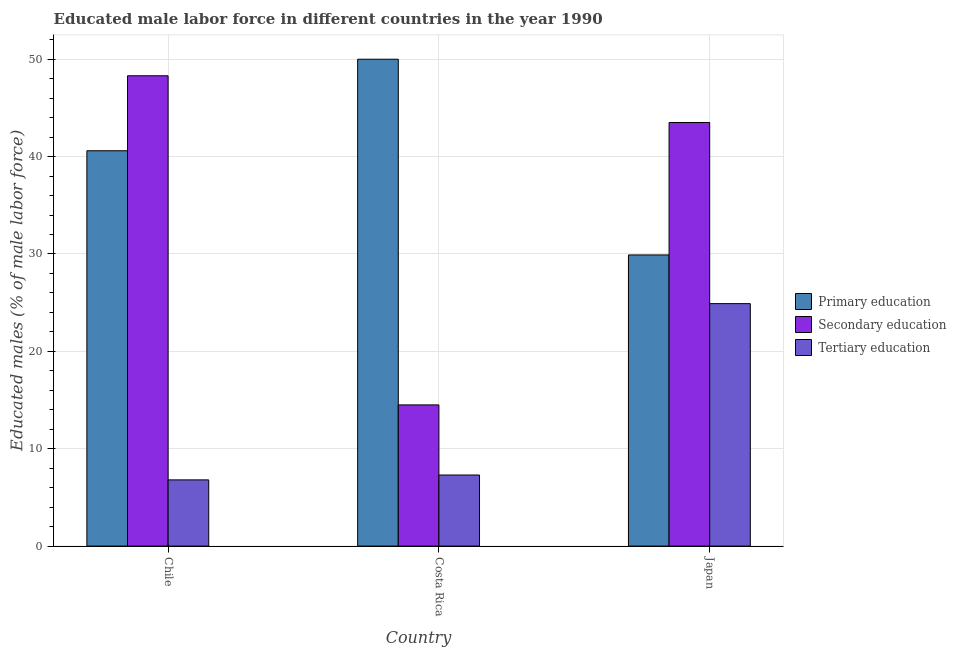How many different coloured bars are there?
Provide a succinct answer. 3. How many groups of bars are there?
Offer a very short reply. 3. Are the number of bars per tick equal to the number of legend labels?
Give a very brief answer. Yes. Are the number of bars on each tick of the X-axis equal?
Your answer should be very brief. Yes. What is the label of the 3rd group of bars from the left?
Your response must be concise. Japan. What is the percentage of male labor force who received primary education in Chile?
Give a very brief answer. 40.6. Across all countries, what is the maximum percentage of male labor force who received secondary education?
Keep it short and to the point. 48.3. Across all countries, what is the minimum percentage of male labor force who received secondary education?
Provide a short and direct response. 14.5. In which country was the percentage of male labor force who received primary education maximum?
Give a very brief answer. Costa Rica. What is the total percentage of male labor force who received tertiary education in the graph?
Offer a terse response. 39. What is the difference between the percentage of male labor force who received primary education in Chile and that in Costa Rica?
Provide a short and direct response. -9.4. What is the difference between the percentage of male labor force who received primary education in Japan and the percentage of male labor force who received tertiary education in Costa Rica?
Provide a short and direct response. 22.6. What is the average percentage of male labor force who received tertiary education per country?
Give a very brief answer. 13. In how many countries, is the percentage of male labor force who received secondary education greater than 18 %?
Give a very brief answer. 2. What is the ratio of the percentage of male labor force who received secondary education in Chile to that in Japan?
Your response must be concise. 1.11. What is the difference between the highest and the second highest percentage of male labor force who received primary education?
Ensure brevity in your answer.  9.4. What is the difference between the highest and the lowest percentage of male labor force who received secondary education?
Make the answer very short. 33.8. Is the sum of the percentage of male labor force who received tertiary education in Chile and Costa Rica greater than the maximum percentage of male labor force who received primary education across all countries?
Offer a very short reply. No. What does the 2nd bar from the left in Costa Rica represents?
Your answer should be compact. Secondary education. Is it the case that in every country, the sum of the percentage of male labor force who received primary education and percentage of male labor force who received secondary education is greater than the percentage of male labor force who received tertiary education?
Your response must be concise. Yes. Are all the bars in the graph horizontal?
Provide a succinct answer. No. Does the graph contain grids?
Ensure brevity in your answer.  Yes. How many legend labels are there?
Offer a terse response. 3. What is the title of the graph?
Offer a terse response. Educated male labor force in different countries in the year 1990. Does "Domestic" appear as one of the legend labels in the graph?
Provide a succinct answer. No. What is the label or title of the X-axis?
Offer a very short reply. Country. What is the label or title of the Y-axis?
Ensure brevity in your answer.  Educated males (% of male labor force). What is the Educated males (% of male labor force) in Primary education in Chile?
Keep it short and to the point. 40.6. What is the Educated males (% of male labor force) in Secondary education in Chile?
Your answer should be very brief. 48.3. What is the Educated males (% of male labor force) in Tertiary education in Chile?
Offer a terse response. 6.8. What is the Educated males (% of male labor force) of Primary education in Costa Rica?
Your answer should be very brief. 50. What is the Educated males (% of male labor force) in Secondary education in Costa Rica?
Offer a very short reply. 14.5. What is the Educated males (% of male labor force) of Tertiary education in Costa Rica?
Keep it short and to the point. 7.3. What is the Educated males (% of male labor force) in Primary education in Japan?
Give a very brief answer. 29.9. What is the Educated males (% of male labor force) in Secondary education in Japan?
Offer a very short reply. 43.5. What is the Educated males (% of male labor force) in Tertiary education in Japan?
Make the answer very short. 24.9. Across all countries, what is the maximum Educated males (% of male labor force) of Secondary education?
Your answer should be compact. 48.3. Across all countries, what is the maximum Educated males (% of male labor force) of Tertiary education?
Keep it short and to the point. 24.9. Across all countries, what is the minimum Educated males (% of male labor force) in Primary education?
Your answer should be compact. 29.9. Across all countries, what is the minimum Educated males (% of male labor force) of Tertiary education?
Provide a succinct answer. 6.8. What is the total Educated males (% of male labor force) of Primary education in the graph?
Your answer should be compact. 120.5. What is the total Educated males (% of male labor force) in Secondary education in the graph?
Keep it short and to the point. 106.3. What is the total Educated males (% of male labor force) of Tertiary education in the graph?
Give a very brief answer. 39. What is the difference between the Educated males (% of male labor force) in Secondary education in Chile and that in Costa Rica?
Offer a terse response. 33.8. What is the difference between the Educated males (% of male labor force) in Tertiary education in Chile and that in Costa Rica?
Keep it short and to the point. -0.5. What is the difference between the Educated males (% of male labor force) in Primary education in Chile and that in Japan?
Provide a succinct answer. 10.7. What is the difference between the Educated males (% of male labor force) of Secondary education in Chile and that in Japan?
Your answer should be very brief. 4.8. What is the difference between the Educated males (% of male labor force) of Tertiary education in Chile and that in Japan?
Your response must be concise. -18.1. What is the difference between the Educated males (% of male labor force) in Primary education in Costa Rica and that in Japan?
Your response must be concise. 20.1. What is the difference between the Educated males (% of male labor force) of Tertiary education in Costa Rica and that in Japan?
Provide a succinct answer. -17.6. What is the difference between the Educated males (% of male labor force) of Primary education in Chile and the Educated males (% of male labor force) of Secondary education in Costa Rica?
Your answer should be compact. 26.1. What is the difference between the Educated males (% of male labor force) in Primary education in Chile and the Educated males (% of male labor force) in Tertiary education in Costa Rica?
Provide a succinct answer. 33.3. What is the difference between the Educated males (% of male labor force) in Secondary education in Chile and the Educated males (% of male labor force) in Tertiary education in Costa Rica?
Offer a terse response. 41. What is the difference between the Educated males (% of male labor force) of Primary education in Chile and the Educated males (% of male labor force) of Tertiary education in Japan?
Give a very brief answer. 15.7. What is the difference between the Educated males (% of male labor force) of Secondary education in Chile and the Educated males (% of male labor force) of Tertiary education in Japan?
Your answer should be very brief. 23.4. What is the difference between the Educated males (% of male labor force) of Primary education in Costa Rica and the Educated males (% of male labor force) of Tertiary education in Japan?
Provide a short and direct response. 25.1. What is the average Educated males (% of male labor force) in Primary education per country?
Your answer should be compact. 40.17. What is the average Educated males (% of male labor force) in Secondary education per country?
Your response must be concise. 35.43. What is the difference between the Educated males (% of male labor force) of Primary education and Educated males (% of male labor force) of Tertiary education in Chile?
Provide a succinct answer. 33.8. What is the difference between the Educated males (% of male labor force) in Secondary education and Educated males (% of male labor force) in Tertiary education in Chile?
Give a very brief answer. 41.5. What is the difference between the Educated males (% of male labor force) in Primary education and Educated males (% of male labor force) in Secondary education in Costa Rica?
Your answer should be very brief. 35.5. What is the difference between the Educated males (% of male labor force) in Primary education and Educated males (% of male labor force) in Tertiary education in Costa Rica?
Provide a succinct answer. 42.7. What is the difference between the Educated males (% of male labor force) of Secondary education and Educated males (% of male labor force) of Tertiary education in Costa Rica?
Your answer should be compact. 7.2. What is the difference between the Educated males (% of male labor force) of Secondary education and Educated males (% of male labor force) of Tertiary education in Japan?
Provide a short and direct response. 18.6. What is the ratio of the Educated males (% of male labor force) in Primary education in Chile to that in Costa Rica?
Give a very brief answer. 0.81. What is the ratio of the Educated males (% of male labor force) in Secondary education in Chile to that in Costa Rica?
Provide a short and direct response. 3.33. What is the ratio of the Educated males (% of male labor force) in Tertiary education in Chile to that in Costa Rica?
Give a very brief answer. 0.93. What is the ratio of the Educated males (% of male labor force) in Primary education in Chile to that in Japan?
Make the answer very short. 1.36. What is the ratio of the Educated males (% of male labor force) of Secondary education in Chile to that in Japan?
Give a very brief answer. 1.11. What is the ratio of the Educated males (% of male labor force) of Tertiary education in Chile to that in Japan?
Keep it short and to the point. 0.27. What is the ratio of the Educated males (% of male labor force) of Primary education in Costa Rica to that in Japan?
Provide a short and direct response. 1.67. What is the ratio of the Educated males (% of male labor force) in Tertiary education in Costa Rica to that in Japan?
Offer a terse response. 0.29. What is the difference between the highest and the second highest Educated males (% of male labor force) in Primary education?
Provide a short and direct response. 9.4. What is the difference between the highest and the second highest Educated males (% of male labor force) in Secondary education?
Make the answer very short. 4.8. What is the difference between the highest and the lowest Educated males (% of male labor force) in Primary education?
Ensure brevity in your answer.  20.1. What is the difference between the highest and the lowest Educated males (% of male labor force) of Secondary education?
Your answer should be compact. 33.8. 